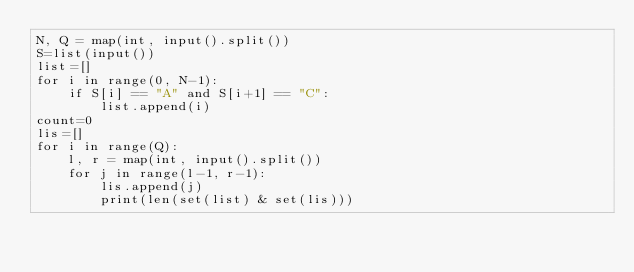<code> <loc_0><loc_0><loc_500><loc_500><_Python_>N, Q = map(int, input().split())
S=list(input())
list=[]
for i in range(0, N-1):
    if S[i] == "A" and S[i+1] == "C":
        list.append(i)
count=0
lis=[]
for i in range(Q):
    l, r = map(int, input().split())
    for j in range(l-1, r-1):
        lis.append(j)
        print(len(set(list) & set(lis)))</code> 